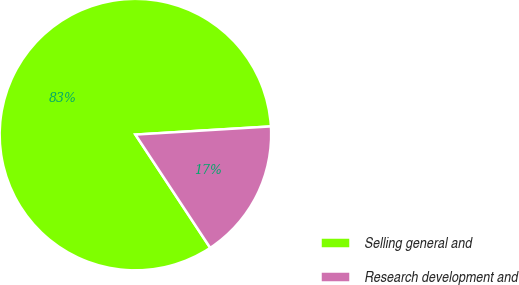Convert chart. <chart><loc_0><loc_0><loc_500><loc_500><pie_chart><fcel>Selling general and<fcel>Research development and<nl><fcel>83.33%<fcel>16.67%<nl></chart> 